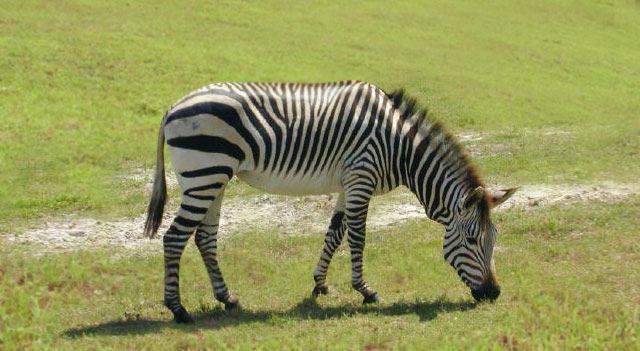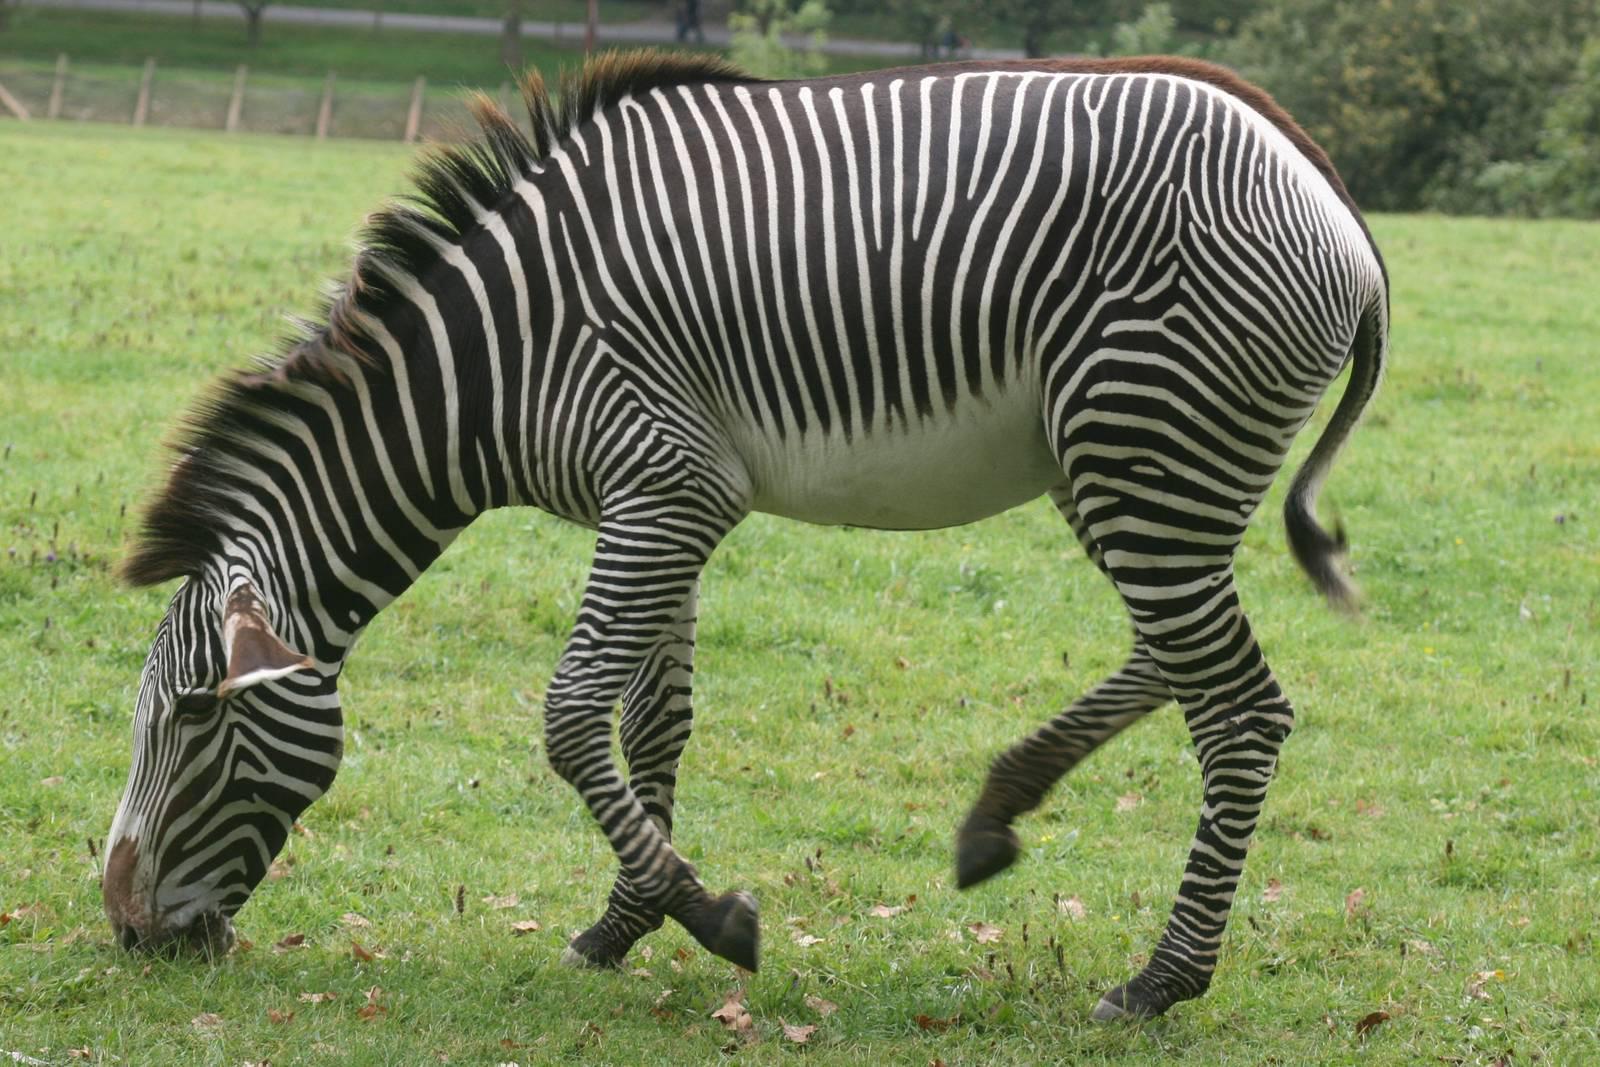The first image is the image on the left, the second image is the image on the right. For the images displayed, is the sentence "The right image contains two zebras." factually correct? Answer yes or no. No. The first image is the image on the left, the second image is the image on the right. Examine the images to the left and right. Is the description "The left image contains one rightward turned standing zebra in profile, with its head bent to the grass, and the right image includes an adult standing leftward-turned zebra with one back hoof raised." accurate? Answer yes or no. Yes. 